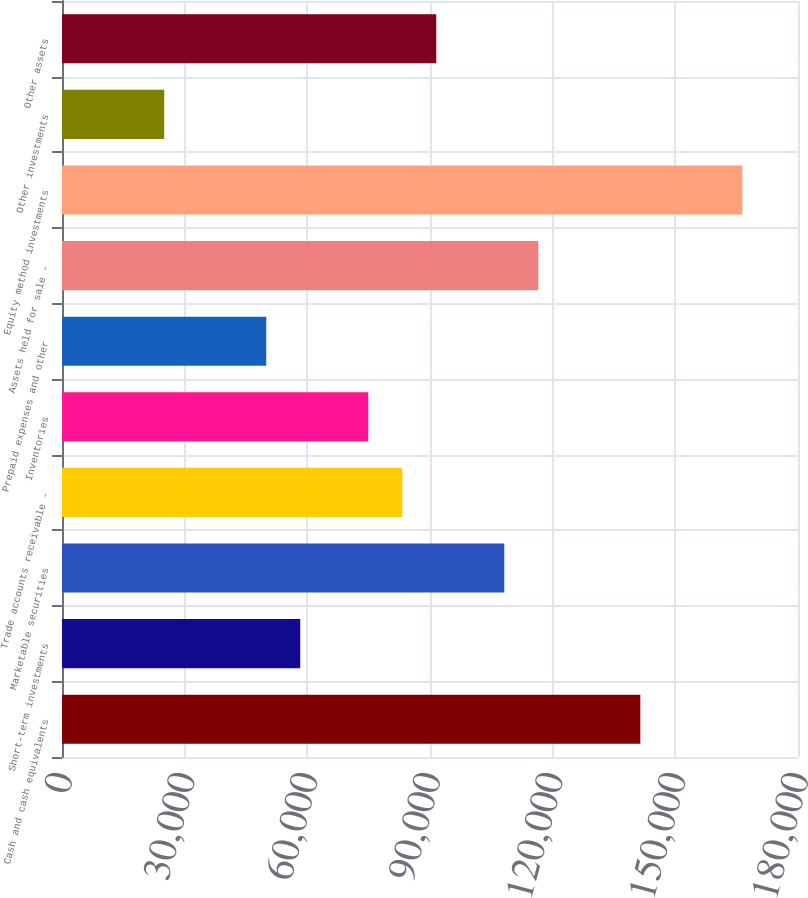<chart> <loc_0><loc_0><loc_500><loc_500><bar_chart><fcel>Cash and cash equivalents<fcel>Short-term investments<fcel>Marketable securities<fcel>Trade accounts receivable -<fcel>Inventories<fcel>Prepaid expenses and other<fcel>Assets held for sale -<fcel>Equity method investments<fcel>Other investments<fcel>Other assets<nl><fcel>141432<fcel>58266.5<fcel>108166<fcel>83216<fcel>74899.5<fcel>49950<fcel>116482<fcel>166381<fcel>25000.5<fcel>91532.5<nl></chart> 